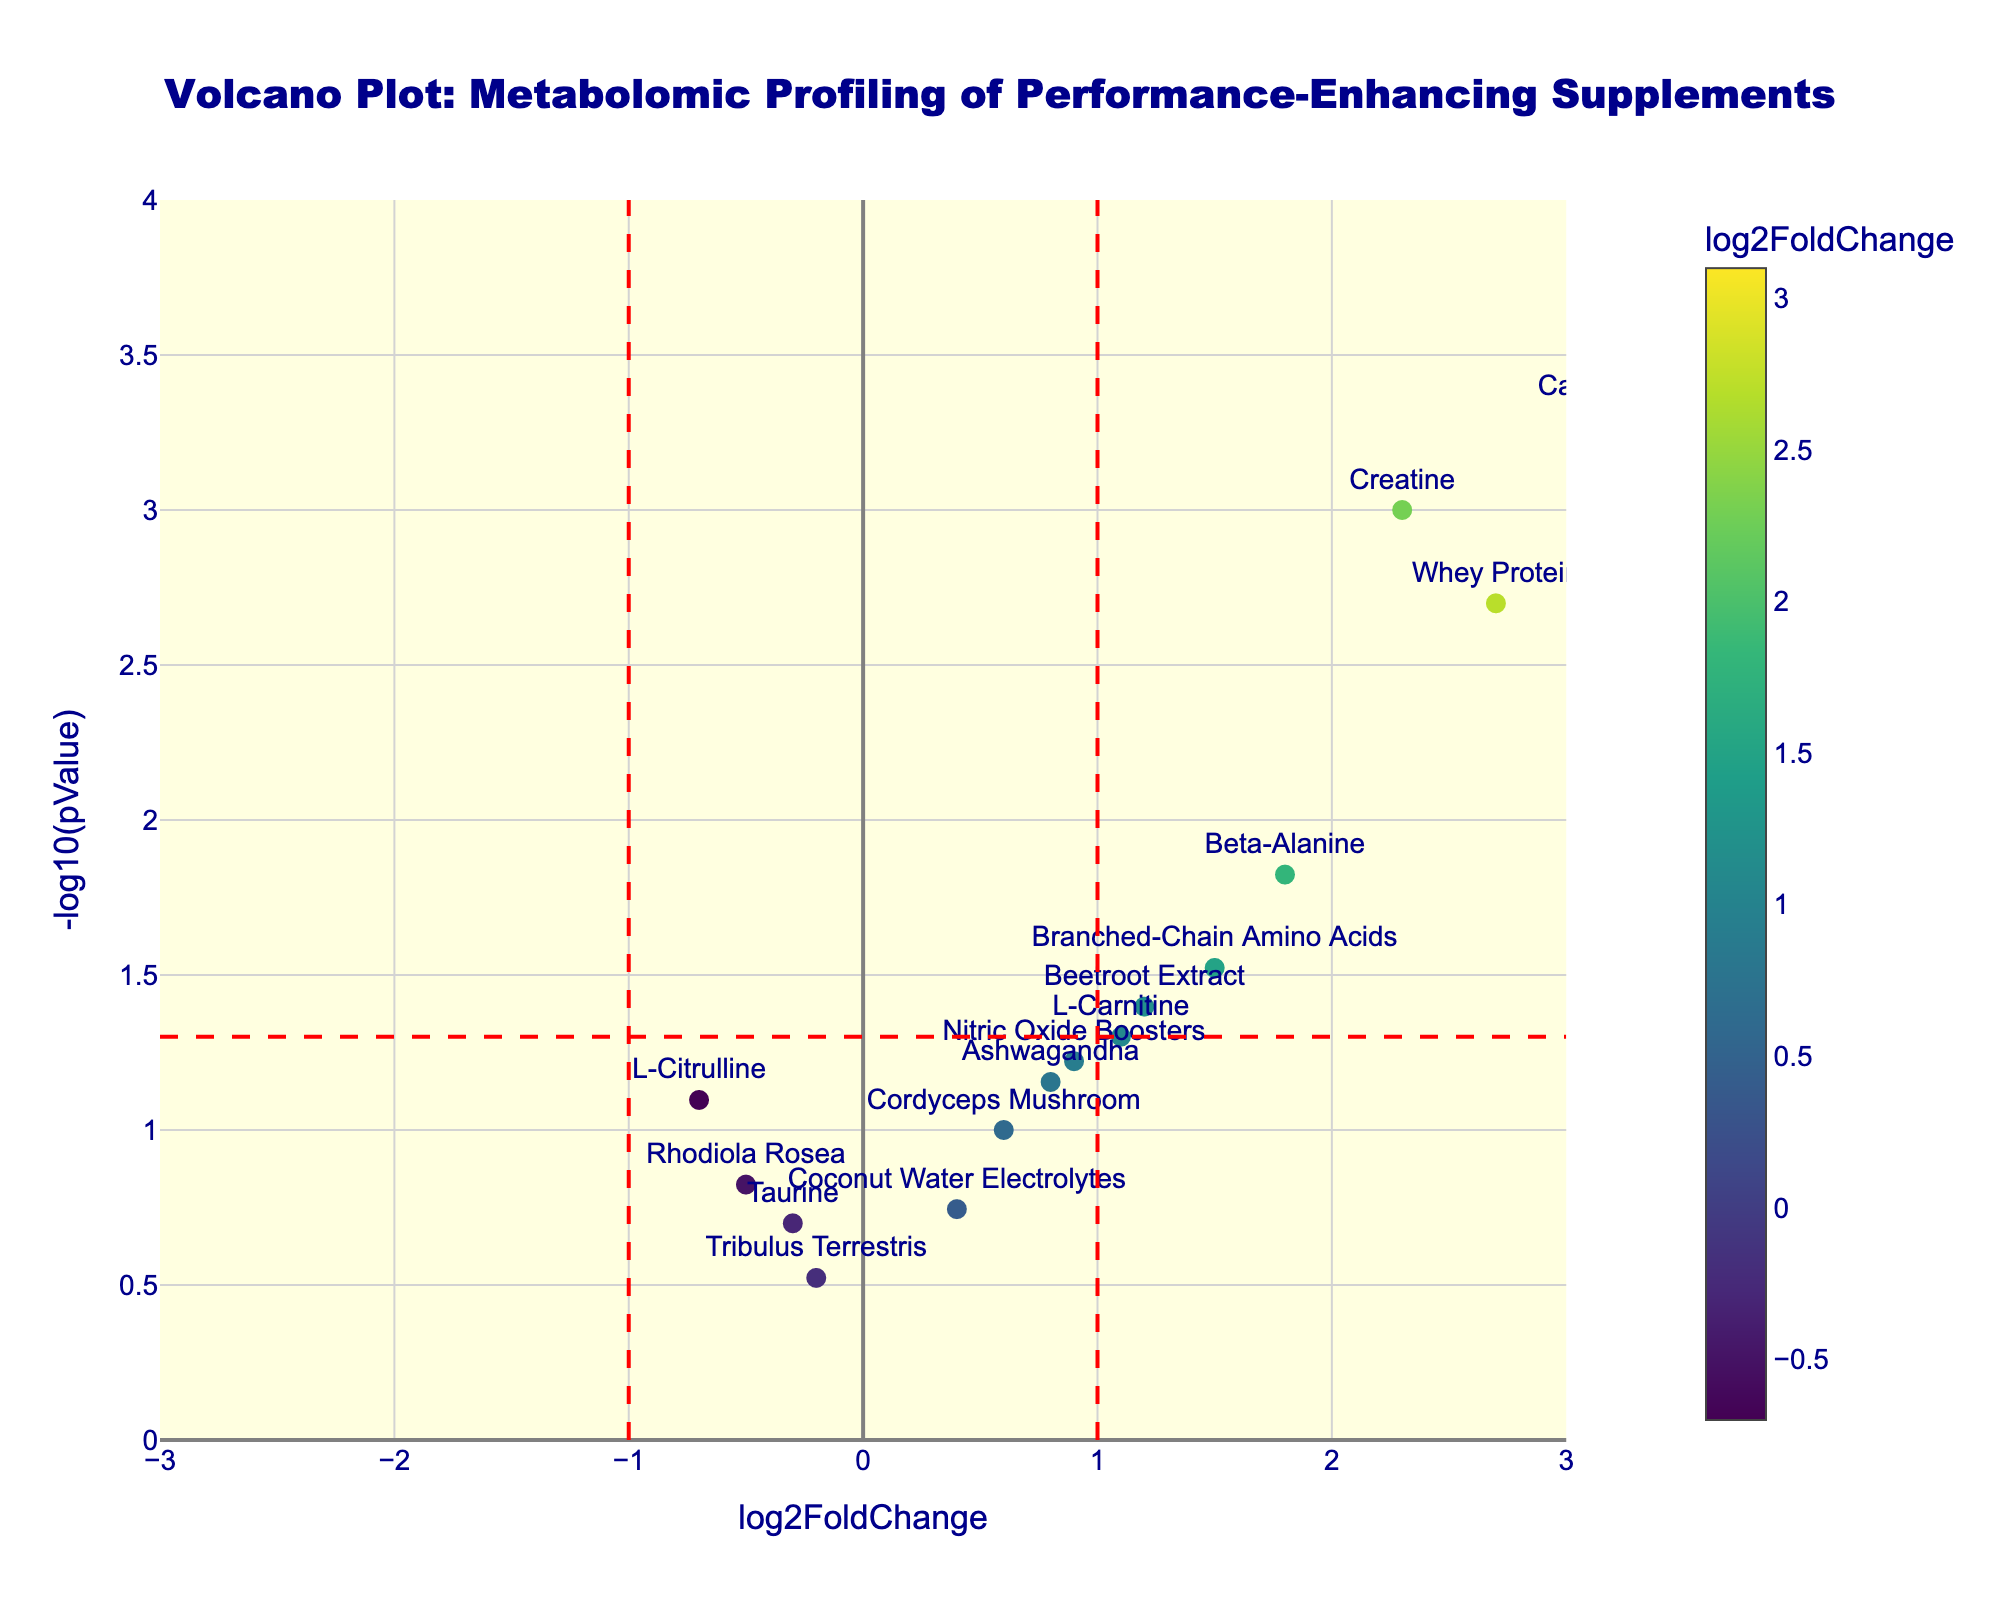What is the title of the figure? The title of the figure is usually displayed at the top and gives an overview of what the plot is about.
Answer: "Volcano Plot: Metabolomic Profiling of Performance-Enhancing Supplements" What does the x-axis represent? The x-axis typically shows one of the variables being compared in a plot. Here, it represents the "log2FoldChange," indicating the fold change in metabolite levels.
Answer: log2FoldChange What does the y-axis represent? The y-axis usually shows the other variable in a plot. Here, it represents "-log10(pValue)," which is a transformation of the p-value used to assess the statistical significance of the changes.
Answer: -log10(pValue) How many data points are represented in the plot? To find the number of data points, count the markers plotted on the figure. Each marker corresponds to a metabolite.
Answer: 15 Which metabolite has the highest fold change? This can be determined by finding the data point with the maximum x-axis value. In this case, look for the highest log2FoldChange.
Answer: Caffeine Which metabolite is the most statistically significant? The most statistically significant point will have the highest y-axis value. Look for the maximum -log10(pValue) in the plot.
Answer: Caffeine Which metabolites have a negative fold change? Negative fold changes are shown on the left side of the x-axis (negative log2FoldChange). Observing these points gives the answer.
Answer: L-Citrulline, Taurine, Rhodiola Rosea, Tribulus Terrestris How many metabolites have a p-value less than 0.05? This can be determined by counting data points above the red horizontal line, which represents the threshold of -log10(pValue) for a p-value of 0.05.
Answer: 6 Which metabolite shows a fold change between 1.0 and 2.0? Identify data points where the x-axis (log2FoldChange) values are between 1.0 and 2.0.
Answer: Beta-Alanine, Branched-Chain Amino Acids, Beetroot Extract, L-Carnitine 